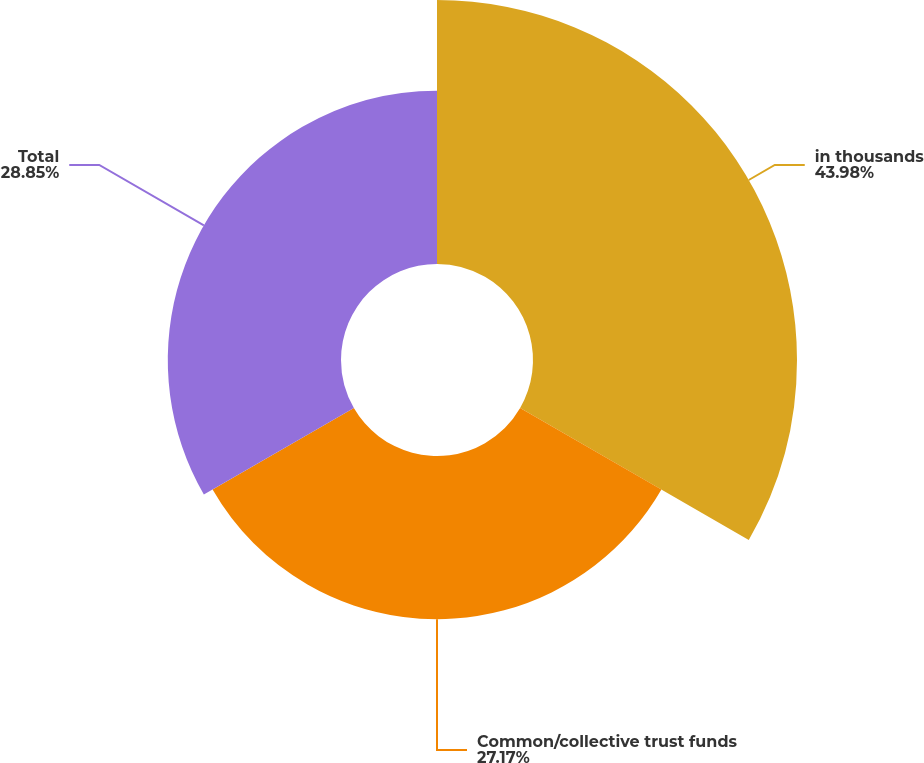Convert chart to OTSL. <chart><loc_0><loc_0><loc_500><loc_500><pie_chart><fcel>in thousands<fcel>Common/collective trust funds<fcel>Total<nl><fcel>43.97%<fcel>27.17%<fcel>28.85%<nl></chart> 